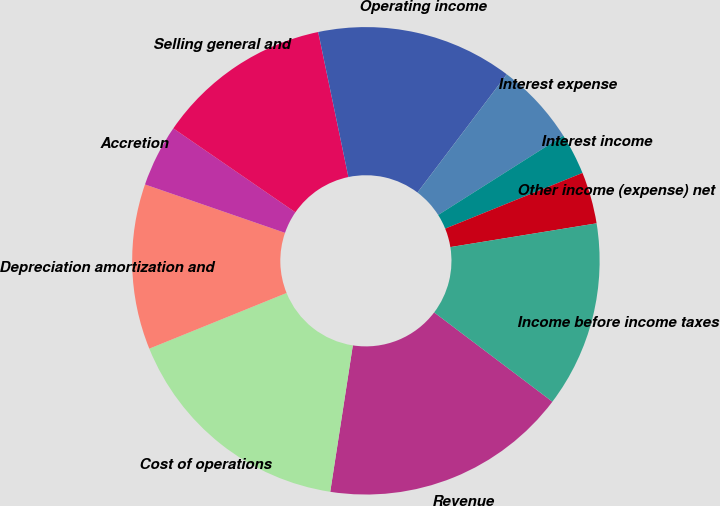<chart> <loc_0><loc_0><loc_500><loc_500><pie_chart><fcel>Revenue<fcel>Cost of operations<fcel>Depreciation amortization and<fcel>Accretion<fcel>Selling general and<fcel>Operating income<fcel>Interest expense<fcel>Interest income<fcel>Other income (expense) net<fcel>Income before income taxes<nl><fcel>17.14%<fcel>16.43%<fcel>11.43%<fcel>4.29%<fcel>12.14%<fcel>13.57%<fcel>5.71%<fcel>2.86%<fcel>3.57%<fcel>12.86%<nl></chart> 